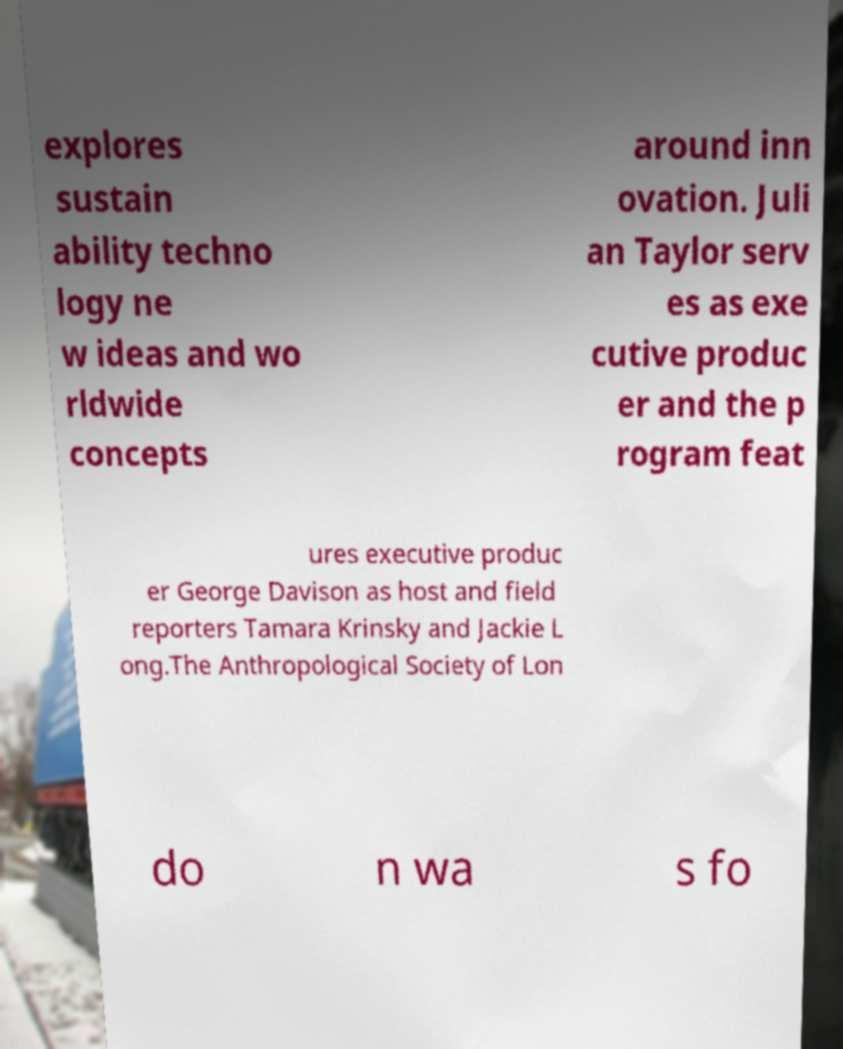Can you read and provide the text displayed in the image?This photo seems to have some interesting text. Can you extract and type it out for me? explores sustain ability techno logy ne w ideas and wo rldwide concepts around inn ovation. Juli an Taylor serv es as exe cutive produc er and the p rogram feat ures executive produc er George Davison as host and field reporters Tamara Krinsky and Jackie L ong.The Anthropological Society of Lon do n wa s fo 